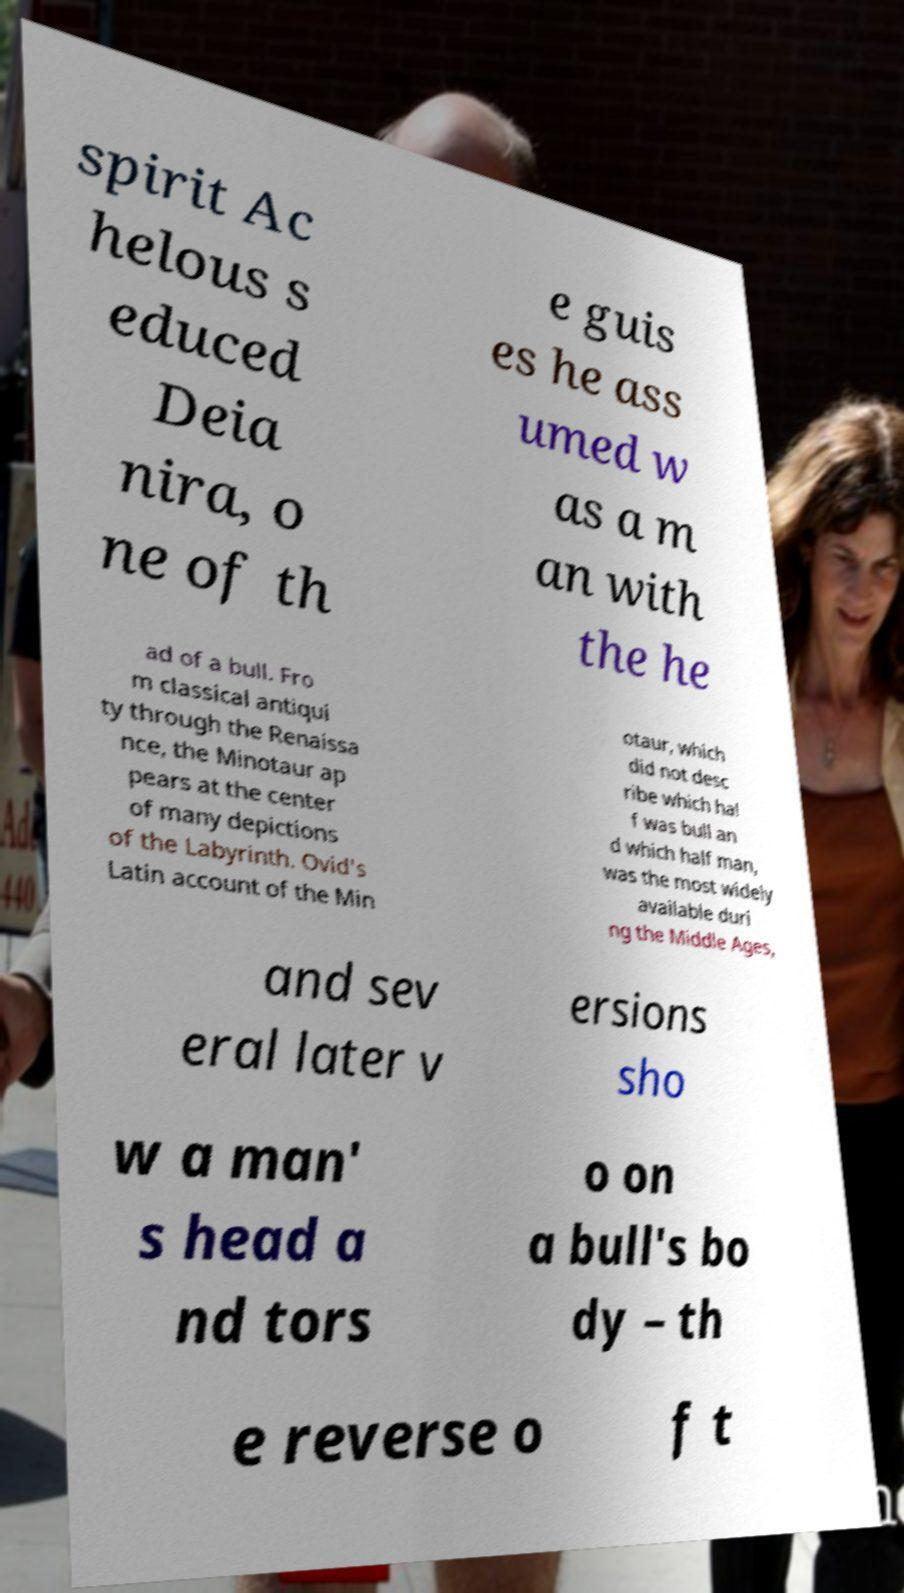Can you accurately transcribe the text from the provided image for me? spirit Ac helous s educed Deia nira, o ne of th e guis es he ass umed w as a m an with the he ad of a bull. Fro m classical antiqui ty through the Renaissa nce, the Minotaur ap pears at the center of many depictions of the Labyrinth. Ovid's Latin account of the Min otaur, which did not desc ribe which hal f was bull an d which half man, was the most widely available duri ng the Middle Ages, and sev eral later v ersions sho w a man' s head a nd tors o on a bull's bo dy – th e reverse o f t 